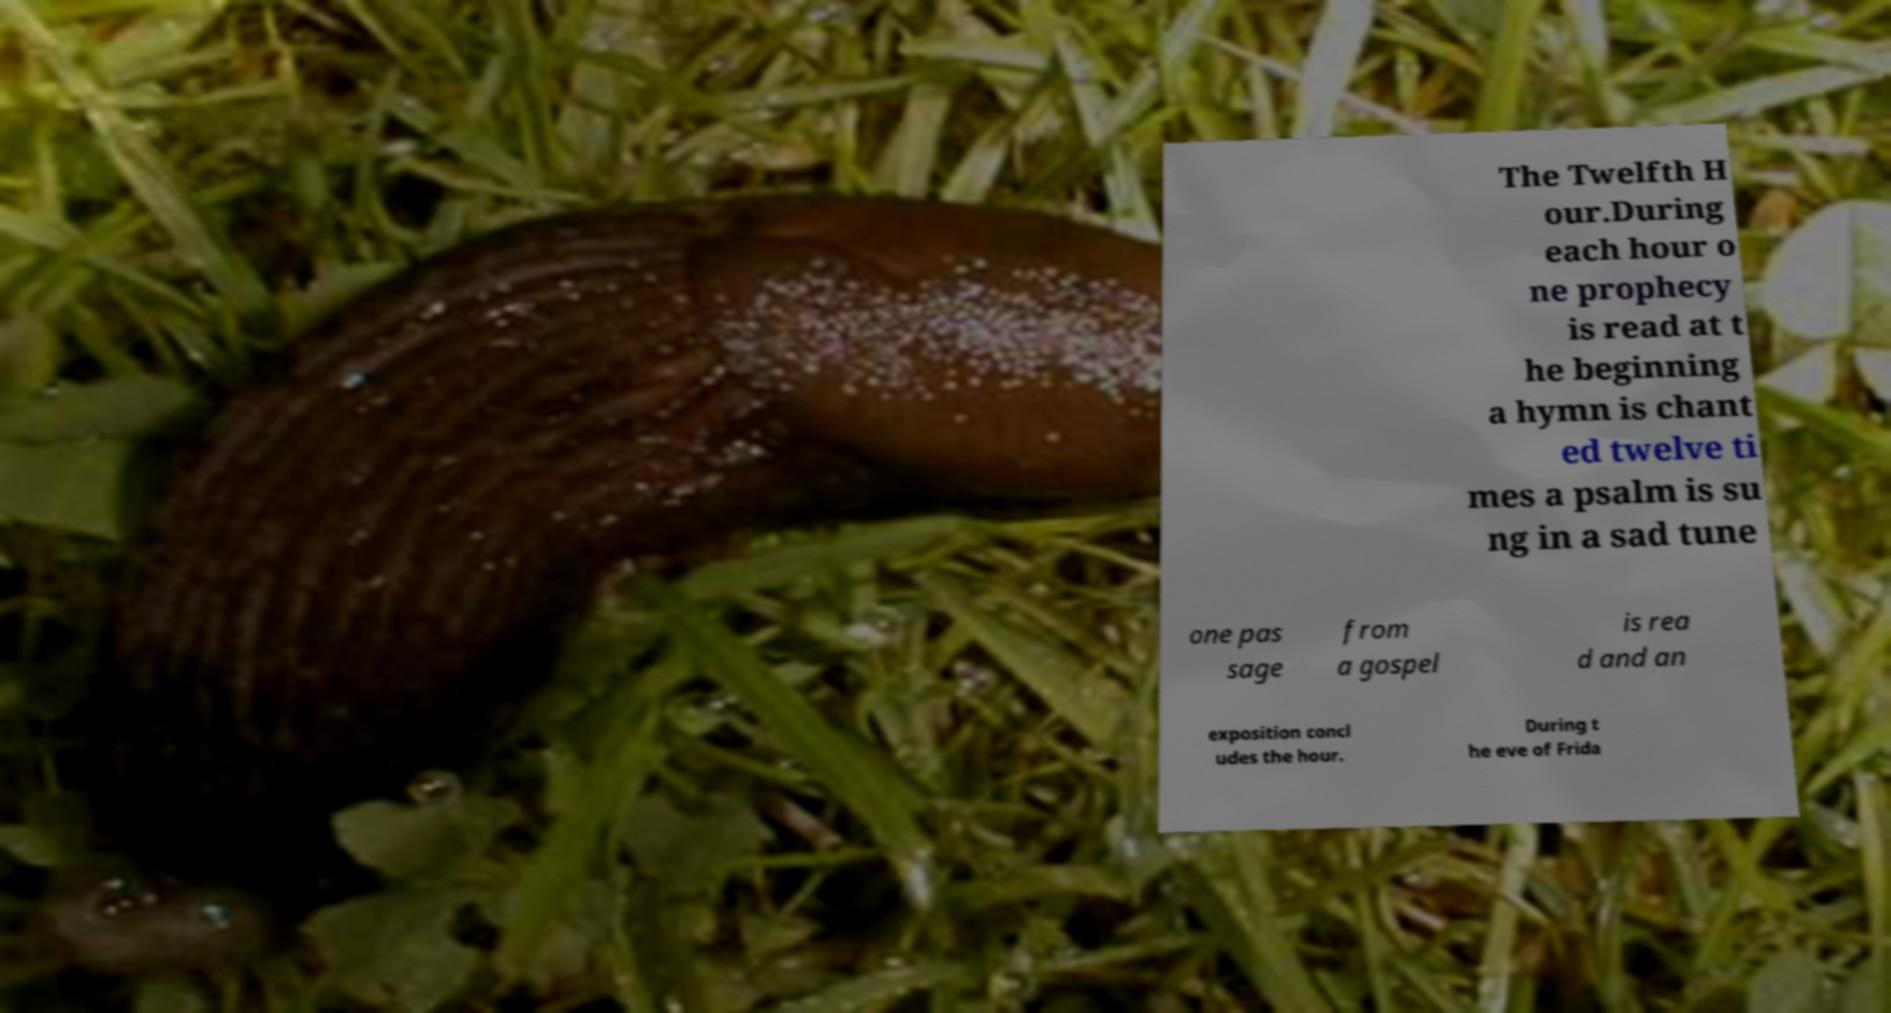Please identify and transcribe the text found in this image. The Twelfth H our.During each hour o ne prophecy is read at t he beginning a hymn is chant ed twelve ti mes a psalm is su ng in a sad tune one pas sage from a gospel is rea d and an exposition concl udes the hour. During t he eve of Frida 